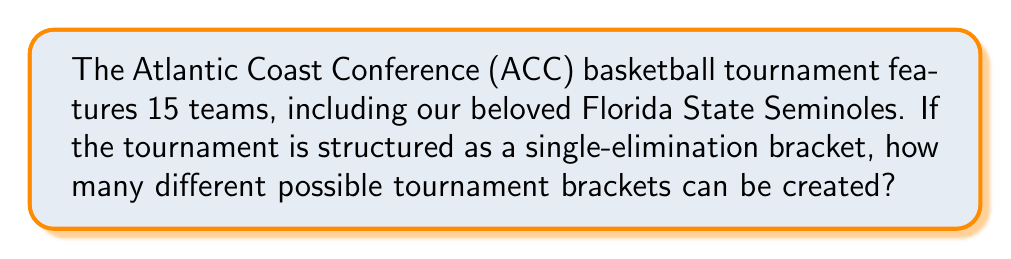Can you solve this math problem? Let's approach this step-by-step:

1) In a single-elimination tournament with 15 teams, we need to determine how many ways we can pair teams in each round.

2) First round:
   - 1 team gets a bye (15 is an odd number)
   - 14 teams play 7 games

3) Second round:
   - 8 teams (7 winners + 1 team with bye) play 4 games

4) Quarter-finals:
   - 4 winners play 2 games

5) Semi-finals:
   - 2 winners play 1 game

6) Finals:
   - 2 winners play 1 game

7) To calculate the total number of possible brackets, we multiply the number of ways to choose teams for each game:

   $$ \text{Total brackets} = \binom{15}{2} \cdot \binom{13}{2} \cdot \binom{11}{2} \cdot \binom{9}{2} \cdot \binom{7}{2} \cdot \binom{5}{2} \cdot \binom{3}{2} $$

8) Calculating each combination:
   $$ \binom{15}{2} = 105, \binom{13}{2} = 78, \binom{11}{2} = 55, \binom{9}{2} = 36, \binom{7}{2} = 21, \binom{5}{2} = 10, \binom{3}{2} = 3 $$

9) Multiplying these values:
   $$ 105 \cdot 78 \cdot 55 \cdot 36 \cdot 21 \cdot 10 \cdot 3 = 638,512,875,000 $$

Therefore, there are 638,512,875,000 possible tournament brackets for a 15-team ACC basketball tournament.
Answer: 638,512,875,000 